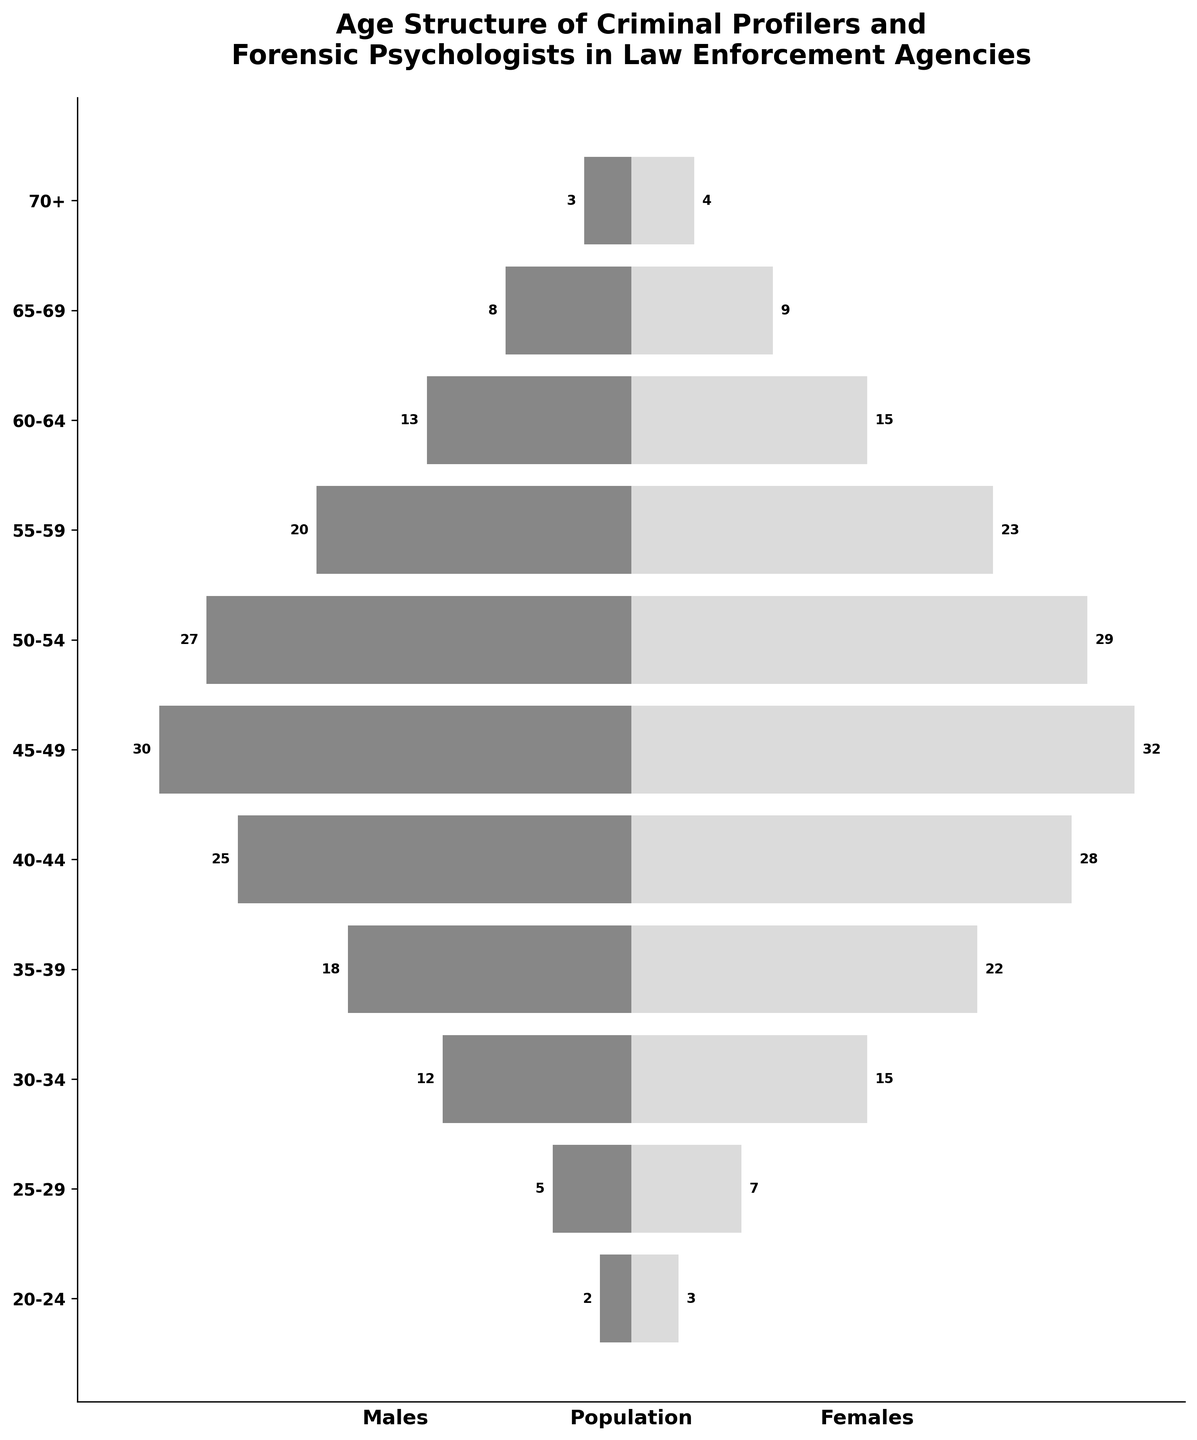What is the title of the figure? The figure's title is at the top and reads "Age Structure of Criminal Profilers and Forensic Psychologists in Law Enforcement Agencies." This gives a contextual overview of the data presented in the population pyramid.
Answer: Age Structure of Criminal Profilers and Forensic Psychologists in Law Enforcement Agencies Which sex has larger bars in the age group 25-29? The males' bars extend to the left while females' bars extend to the right. For the age group 25-29, the females' bar extends further than the males'. This indicates that there are more females than males in this age group.
Answer: Females What is the total number of male and female criminal profilers and forensic psychologists in the 45-49 age group? The population pyramid shows 30 males and 32 females in the 45-49 age group. Adding these numbers together gives the total number for this age group.
Answer: 62 Which age group has the highest number of female professionals? The pyramid indicates the number of females for each age group. By comparing the lengths of the right-side bars, we see that the 45-49 age group has the tallest bar for females, indicating the highest number of female professionals.
Answer: 45-49 What is the difference in the number of males and females in the 60-64 age group? The 60-64 age group shows 13 males and 15 females. The difference between these two numbers can be calculated by subtracting the number of males from the number of females: 15 - 13 = 2.
Answer: 2 How many more females are there than males in the 55-59 age group? According to the pyramid, there are 20 males and 23 females in the 55-59 age group. Subtracting the number of males from the number of females gives 23 - 20 = 3. Thus, there are 3 more females than males in this age group.
Answer: 3 Compare the number of females in the age group 30-34 to the number of males in the same group. The pyramid shows figures for both genders in the 30-34 age group. By checking the bars, it is evident that there are 15 females and 12 males in this age category. Comparing these two numbers, females are greater than males.
Answer: Females are greater than males What is the sum of male and female professionals aged 50-54? The population pyramid shows 27 males and 29 females in the 50-54 age group. Adding these numbers together gives the total number for this age group: 27 + 29 = 56.
Answer: 56 Which age group has the smallest difference in the number of males and females? To determine this, we need to look at the differences between the male and female figures for each age group. The smallest differences occur in the 20-24, 65-69, and 70+ age groups. The difference is 1 for all three.
Answer: 20-24, 65-69, and 70+ In which age group do males significantly outnumber females? From comparing the length of the left bars (males) and right bars (females) for the relevant age groups, we find that in most cases, females outnumber males. However, none of the age groups show a significant outnumbering of males compared to females. Thus, no significant outnumbering is evident.
Answer: None 